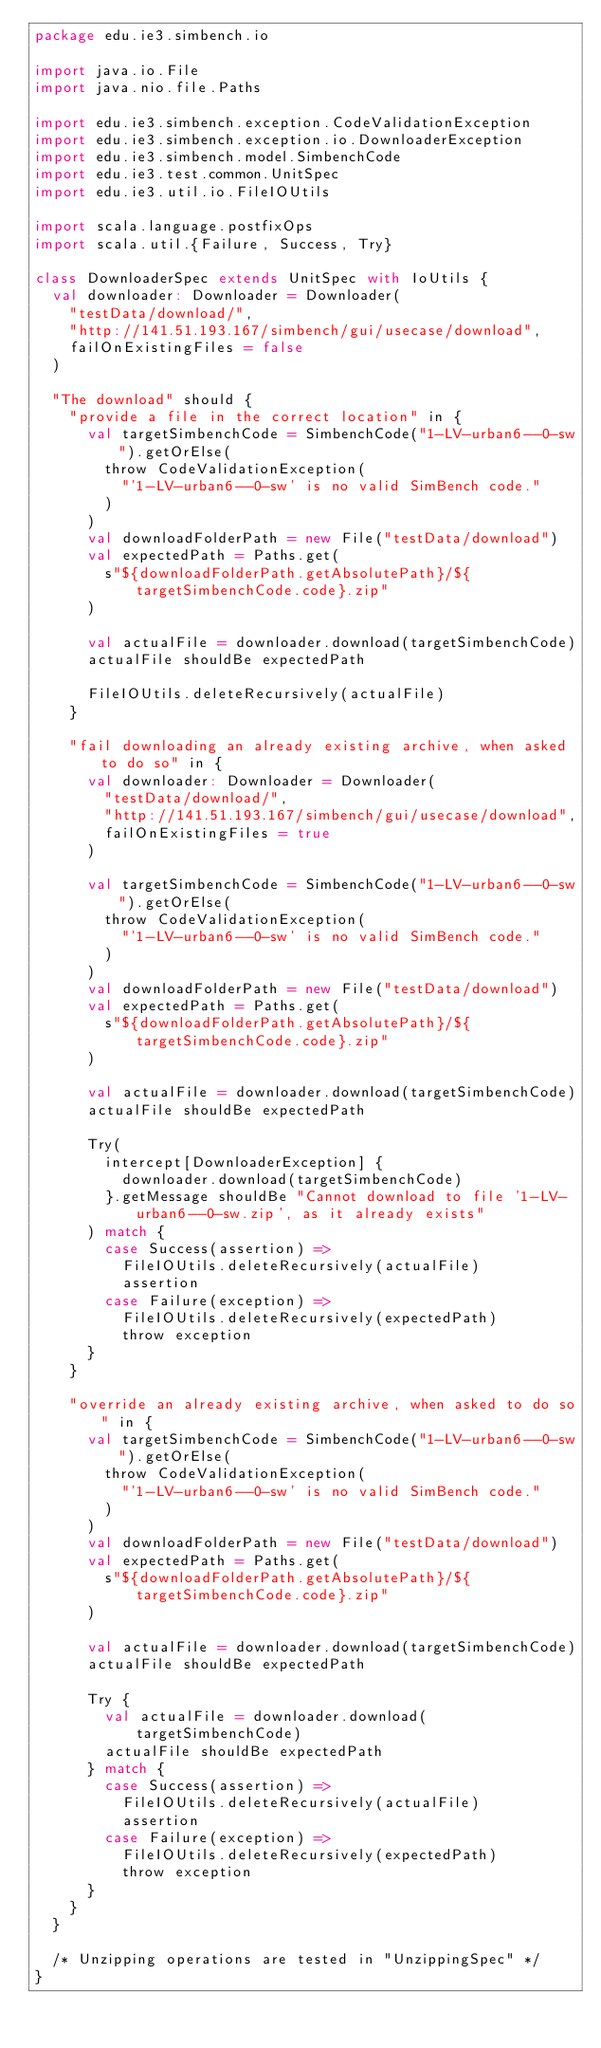Convert code to text. <code><loc_0><loc_0><loc_500><loc_500><_Scala_>package edu.ie3.simbench.io

import java.io.File
import java.nio.file.Paths

import edu.ie3.simbench.exception.CodeValidationException
import edu.ie3.simbench.exception.io.DownloaderException
import edu.ie3.simbench.model.SimbenchCode
import edu.ie3.test.common.UnitSpec
import edu.ie3.util.io.FileIOUtils

import scala.language.postfixOps
import scala.util.{Failure, Success, Try}

class DownloaderSpec extends UnitSpec with IoUtils {
  val downloader: Downloader = Downloader(
    "testData/download/",
    "http://141.51.193.167/simbench/gui/usecase/download",
    failOnExistingFiles = false
  )

  "The download" should {
    "provide a file in the correct location" in {
      val targetSimbenchCode = SimbenchCode("1-LV-urban6--0-sw").getOrElse(
        throw CodeValidationException(
          "'1-LV-urban6--0-sw' is no valid SimBench code."
        )
      )
      val downloadFolderPath = new File("testData/download")
      val expectedPath = Paths.get(
        s"${downloadFolderPath.getAbsolutePath}/${targetSimbenchCode.code}.zip"
      )

      val actualFile = downloader.download(targetSimbenchCode)
      actualFile shouldBe expectedPath

      FileIOUtils.deleteRecursively(actualFile)
    }

    "fail downloading an already existing archive, when asked to do so" in {
      val downloader: Downloader = Downloader(
        "testData/download/",
        "http://141.51.193.167/simbench/gui/usecase/download",
        failOnExistingFiles = true
      )

      val targetSimbenchCode = SimbenchCode("1-LV-urban6--0-sw").getOrElse(
        throw CodeValidationException(
          "'1-LV-urban6--0-sw' is no valid SimBench code."
        )
      )
      val downloadFolderPath = new File("testData/download")
      val expectedPath = Paths.get(
        s"${downloadFolderPath.getAbsolutePath}/${targetSimbenchCode.code}.zip"
      )

      val actualFile = downloader.download(targetSimbenchCode)
      actualFile shouldBe expectedPath

      Try(
        intercept[DownloaderException] {
          downloader.download(targetSimbenchCode)
        }.getMessage shouldBe "Cannot download to file '1-LV-urban6--0-sw.zip', as it already exists"
      ) match {
        case Success(assertion) =>
          FileIOUtils.deleteRecursively(actualFile)
          assertion
        case Failure(exception) =>
          FileIOUtils.deleteRecursively(expectedPath)
          throw exception
      }
    }

    "override an already existing archive, when asked to do so" in {
      val targetSimbenchCode = SimbenchCode("1-LV-urban6--0-sw").getOrElse(
        throw CodeValidationException(
          "'1-LV-urban6--0-sw' is no valid SimBench code."
        )
      )
      val downloadFolderPath = new File("testData/download")
      val expectedPath = Paths.get(
        s"${downloadFolderPath.getAbsolutePath}/${targetSimbenchCode.code}.zip"
      )

      val actualFile = downloader.download(targetSimbenchCode)
      actualFile shouldBe expectedPath

      Try {
        val actualFile = downloader.download(targetSimbenchCode)
        actualFile shouldBe expectedPath
      } match {
        case Success(assertion) =>
          FileIOUtils.deleteRecursively(actualFile)
          assertion
        case Failure(exception) =>
          FileIOUtils.deleteRecursively(expectedPath)
          throw exception
      }
    }
  }

  /* Unzipping operations are tested in "UnzippingSpec" */
}
</code> 